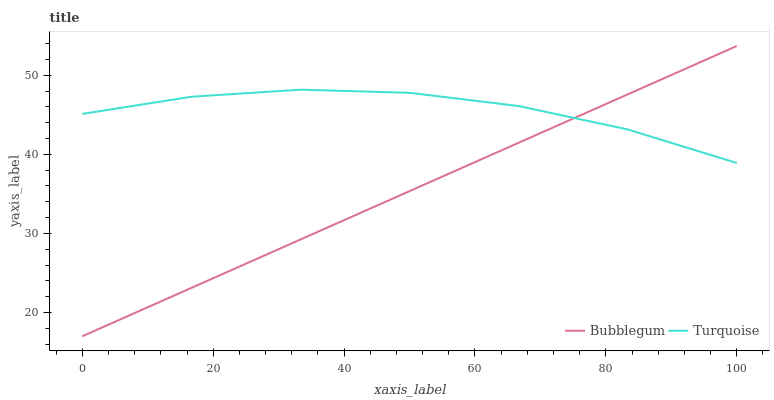Does Bubblegum have the minimum area under the curve?
Answer yes or no. Yes. Does Turquoise have the maximum area under the curve?
Answer yes or no. Yes. Does Bubblegum have the maximum area under the curve?
Answer yes or no. No. Is Bubblegum the smoothest?
Answer yes or no. Yes. Is Turquoise the roughest?
Answer yes or no. Yes. Is Bubblegum the roughest?
Answer yes or no. No. Does Bubblegum have the lowest value?
Answer yes or no. Yes. Does Bubblegum have the highest value?
Answer yes or no. Yes. Does Turquoise intersect Bubblegum?
Answer yes or no. Yes. Is Turquoise less than Bubblegum?
Answer yes or no. No. Is Turquoise greater than Bubblegum?
Answer yes or no. No. 